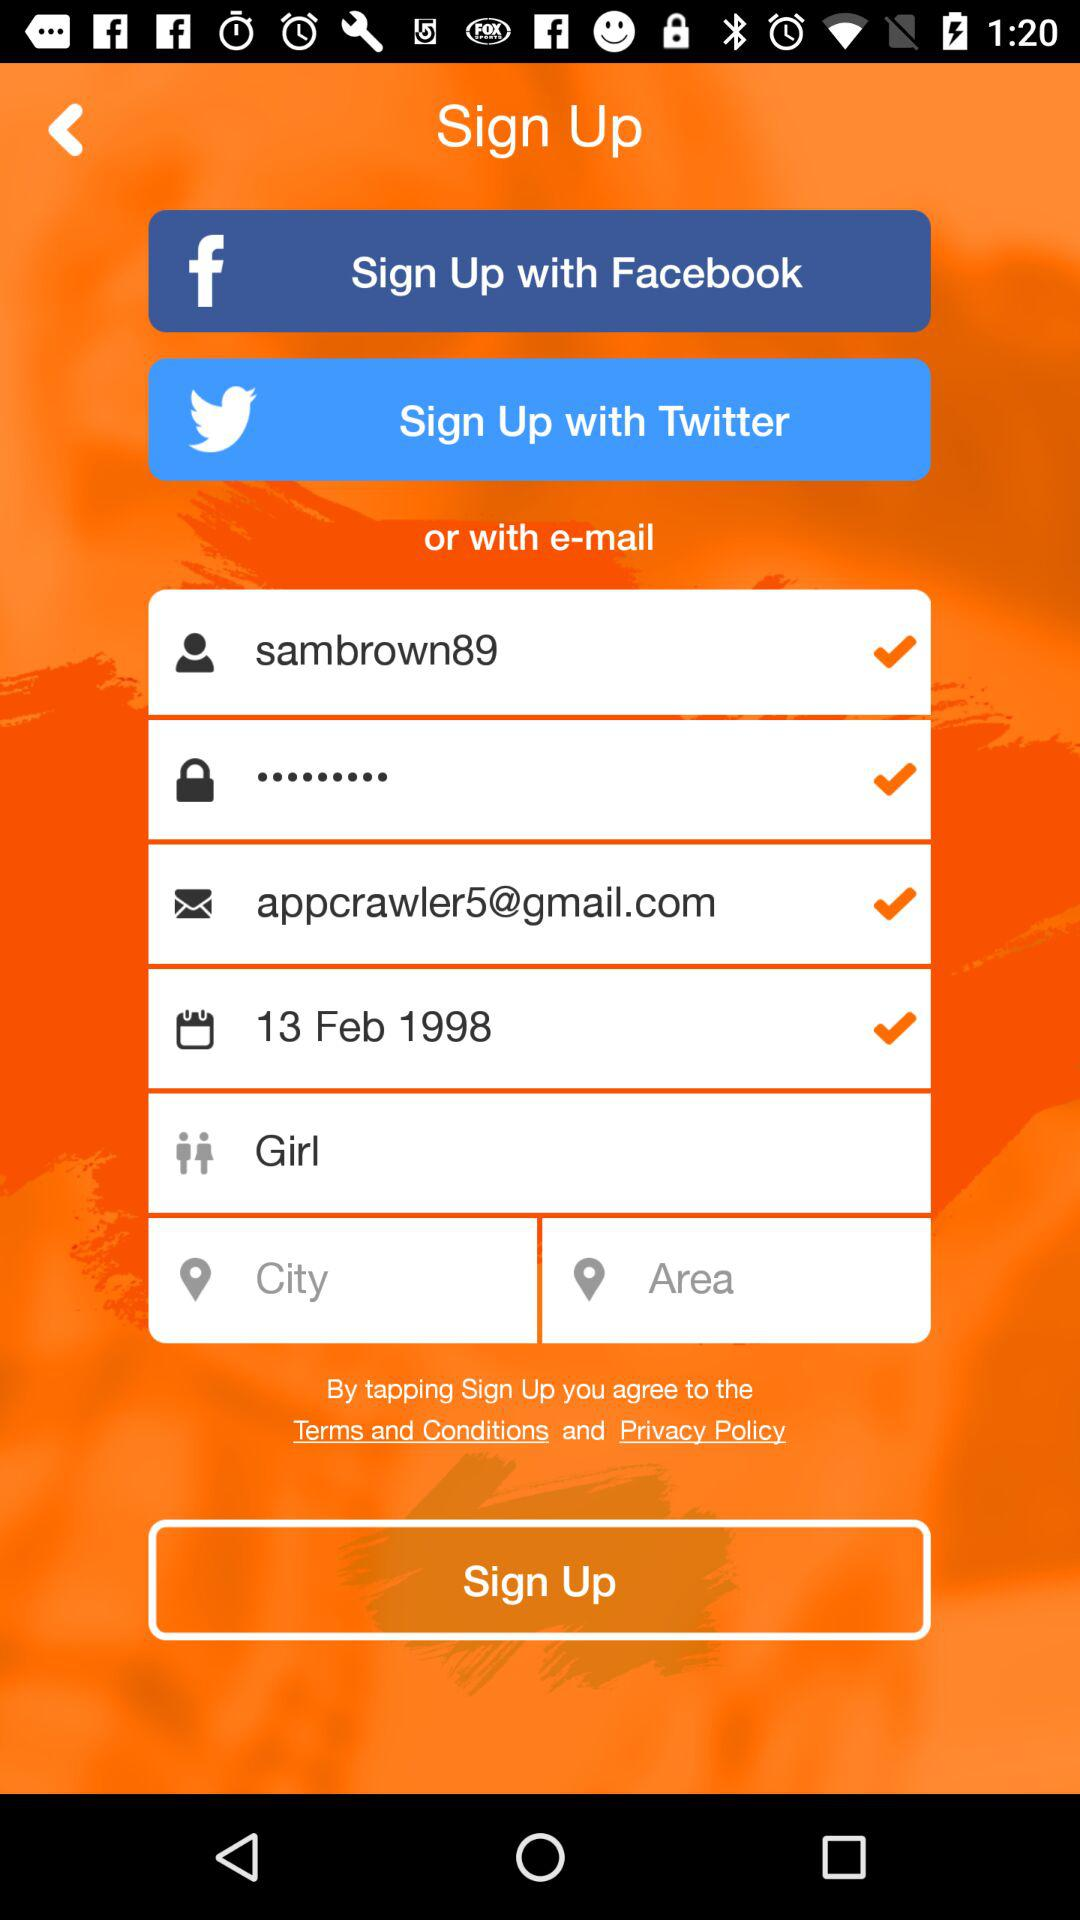What is the username? The username is sambrown89. 